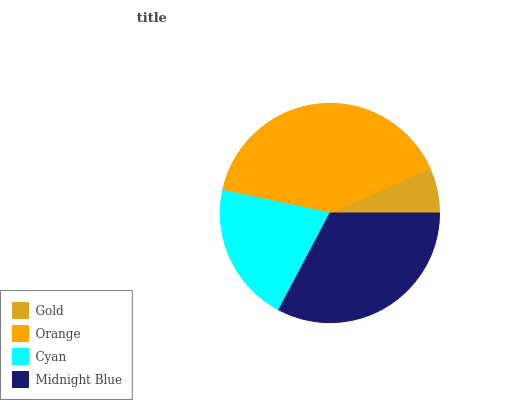Is Gold the minimum?
Answer yes or no. Yes. Is Orange the maximum?
Answer yes or no. Yes. Is Cyan the minimum?
Answer yes or no. No. Is Cyan the maximum?
Answer yes or no. No. Is Orange greater than Cyan?
Answer yes or no. Yes. Is Cyan less than Orange?
Answer yes or no. Yes. Is Cyan greater than Orange?
Answer yes or no. No. Is Orange less than Cyan?
Answer yes or no. No. Is Midnight Blue the high median?
Answer yes or no. Yes. Is Cyan the low median?
Answer yes or no. Yes. Is Gold the high median?
Answer yes or no. No. Is Midnight Blue the low median?
Answer yes or no. No. 